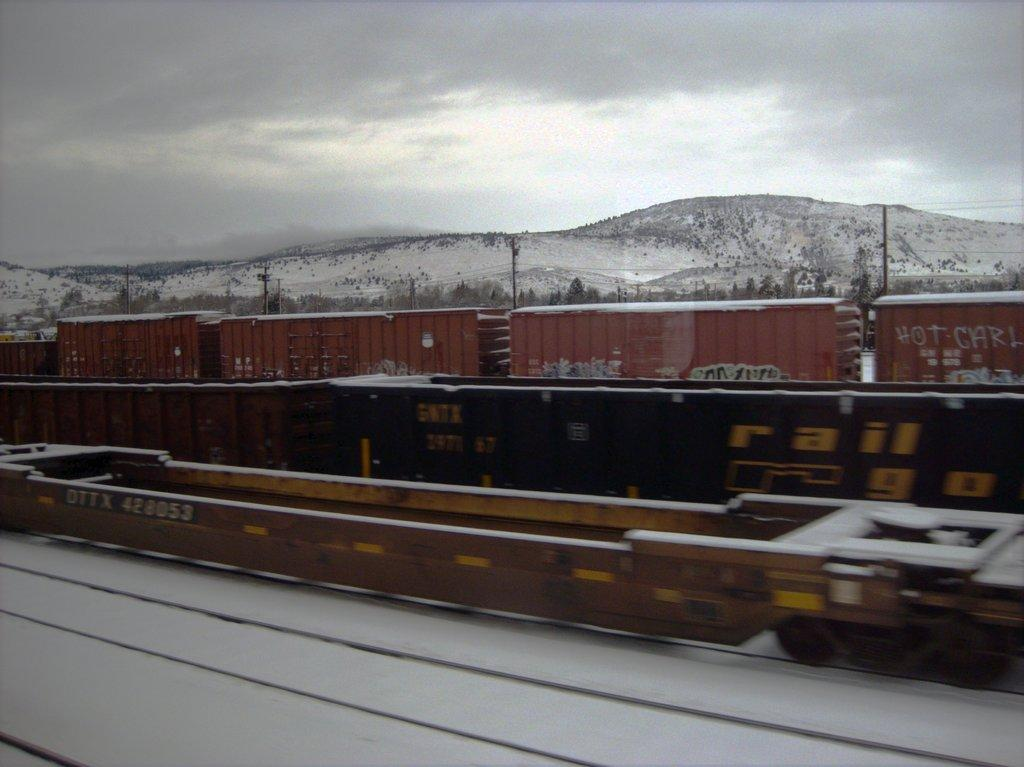What is located in the middle of the image? There are trains in the middle of the image. What is the condition of the ground in the image? The bottom of the image appears to have snow. What type of landscape feature can be seen in the background of the image? There are hills visible at the back side of the image. What is visible at the top of the image? The sky is cloudy and visible at the top of the image. What type of drink is being served in the image? There is no drink present in the image; it features trains, snow, hills, and a cloudy sky. 